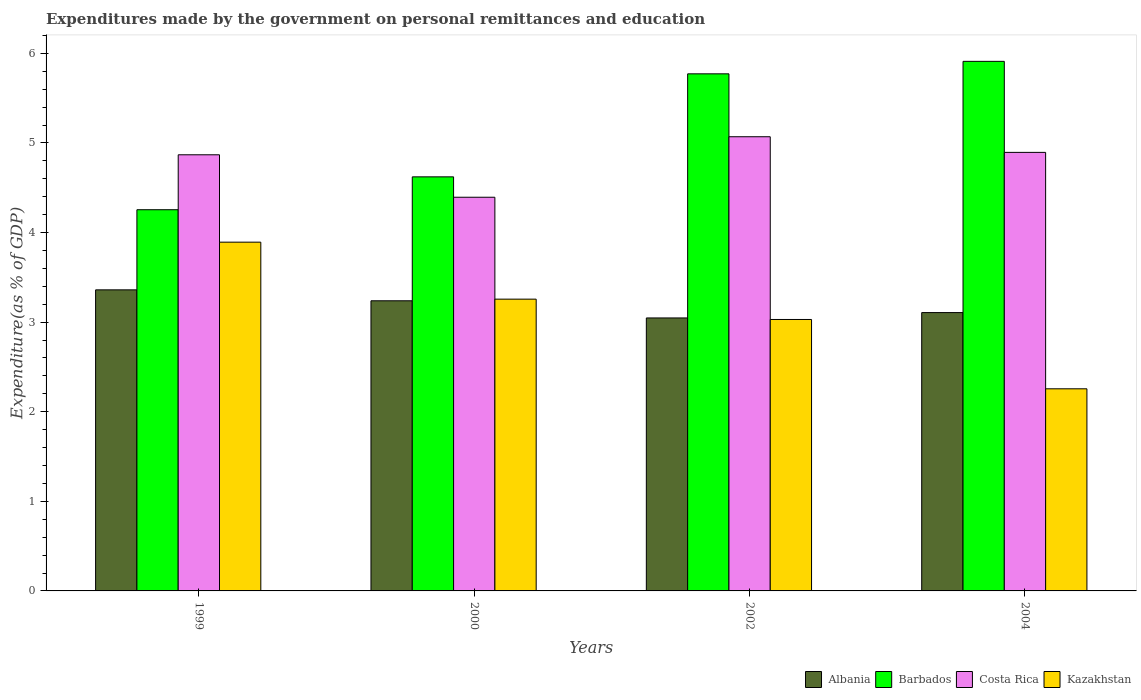How many different coloured bars are there?
Your answer should be compact. 4. How many groups of bars are there?
Make the answer very short. 4. Are the number of bars on each tick of the X-axis equal?
Provide a short and direct response. Yes. How many bars are there on the 1st tick from the left?
Your answer should be compact. 4. How many bars are there on the 4th tick from the right?
Your response must be concise. 4. In how many cases, is the number of bars for a given year not equal to the number of legend labels?
Your answer should be very brief. 0. What is the expenditures made by the government on personal remittances and education in Barbados in 2004?
Your response must be concise. 5.91. Across all years, what is the maximum expenditures made by the government on personal remittances and education in Albania?
Make the answer very short. 3.36. Across all years, what is the minimum expenditures made by the government on personal remittances and education in Costa Rica?
Provide a succinct answer. 4.39. In which year was the expenditures made by the government on personal remittances and education in Barbados maximum?
Your answer should be very brief. 2004. In which year was the expenditures made by the government on personal remittances and education in Kazakhstan minimum?
Offer a terse response. 2004. What is the total expenditures made by the government on personal remittances and education in Costa Rica in the graph?
Keep it short and to the point. 19.23. What is the difference between the expenditures made by the government on personal remittances and education in Albania in 2002 and that in 2004?
Offer a terse response. -0.06. What is the difference between the expenditures made by the government on personal remittances and education in Albania in 2002 and the expenditures made by the government on personal remittances and education in Barbados in 1999?
Ensure brevity in your answer.  -1.21. What is the average expenditures made by the government on personal remittances and education in Barbados per year?
Your response must be concise. 5.14. In the year 1999, what is the difference between the expenditures made by the government on personal remittances and education in Barbados and expenditures made by the government on personal remittances and education in Albania?
Provide a short and direct response. 0.89. In how many years, is the expenditures made by the government on personal remittances and education in Barbados greater than 5.4 %?
Keep it short and to the point. 2. What is the ratio of the expenditures made by the government on personal remittances and education in Costa Rica in 1999 to that in 2004?
Provide a short and direct response. 0.99. Is the expenditures made by the government on personal remittances and education in Costa Rica in 2002 less than that in 2004?
Provide a short and direct response. No. What is the difference between the highest and the second highest expenditures made by the government on personal remittances and education in Costa Rica?
Ensure brevity in your answer.  0.17. What is the difference between the highest and the lowest expenditures made by the government on personal remittances and education in Barbados?
Your answer should be compact. 1.66. In how many years, is the expenditures made by the government on personal remittances and education in Costa Rica greater than the average expenditures made by the government on personal remittances and education in Costa Rica taken over all years?
Your response must be concise. 3. Is it the case that in every year, the sum of the expenditures made by the government on personal remittances and education in Barbados and expenditures made by the government on personal remittances and education in Albania is greater than the sum of expenditures made by the government on personal remittances and education in Costa Rica and expenditures made by the government on personal remittances and education in Kazakhstan?
Ensure brevity in your answer.  Yes. What does the 4th bar from the left in 2004 represents?
Offer a very short reply. Kazakhstan. What does the 1st bar from the right in 2002 represents?
Your response must be concise. Kazakhstan. Is it the case that in every year, the sum of the expenditures made by the government on personal remittances and education in Barbados and expenditures made by the government on personal remittances and education in Costa Rica is greater than the expenditures made by the government on personal remittances and education in Kazakhstan?
Your answer should be compact. Yes. Are all the bars in the graph horizontal?
Offer a terse response. No. How many years are there in the graph?
Your answer should be compact. 4. What is the difference between two consecutive major ticks on the Y-axis?
Offer a terse response. 1. Are the values on the major ticks of Y-axis written in scientific E-notation?
Provide a succinct answer. No. Does the graph contain grids?
Keep it short and to the point. No. How many legend labels are there?
Offer a very short reply. 4. What is the title of the graph?
Keep it short and to the point. Expenditures made by the government on personal remittances and education. What is the label or title of the Y-axis?
Your response must be concise. Expenditure(as % of GDP). What is the Expenditure(as % of GDP) in Albania in 1999?
Provide a short and direct response. 3.36. What is the Expenditure(as % of GDP) of Barbados in 1999?
Provide a succinct answer. 4.25. What is the Expenditure(as % of GDP) in Costa Rica in 1999?
Provide a short and direct response. 4.87. What is the Expenditure(as % of GDP) in Kazakhstan in 1999?
Give a very brief answer. 3.89. What is the Expenditure(as % of GDP) in Albania in 2000?
Provide a succinct answer. 3.24. What is the Expenditure(as % of GDP) in Barbados in 2000?
Offer a terse response. 4.62. What is the Expenditure(as % of GDP) in Costa Rica in 2000?
Provide a short and direct response. 4.39. What is the Expenditure(as % of GDP) in Kazakhstan in 2000?
Offer a very short reply. 3.26. What is the Expenditure(as % of GDP) in Albania in 2002?
Keep it short and to the point. 3.05. What is the Expenditure(as % of GDP) in Barbados in 2002?
Offer a very short reply. 5.77. What is the Expenditure(as % of GDP) of Costa Rica in 2002?
Make the answer very short. 5.07. What is the Expenditure(as % of GDP) in Kazakhstan in 2002?
Your response must be concise. 3.03. What is the Expenditure(as % of GDP) of Albania in 2004?
Keep it short and to the point. 3.11. What is the Expenditure(as % of GDP) in Barbados in 2004?
Your answer should be very brief. 5.91. What is the Expenditure(as % of GDP) of Costa Rica in 2004?
Provide a short and direct response. 4.89. What is the Expenditure(as % of GDP) in Kazakhstan in 2004?
Your response must be concise. 2.26. Across all years, what is the maximum Expenditure(as % of GDP) of Albania?
Give a very brief answer. 3.36. Across all years, what is the maximum Expenditure(as % of GDP) in Barbados?
Your response must be concise. 5.91. Across all years, what is the maximum Expenditure(as % of GDP) in Costa Rica?
Make the answer very short. 5.07. Across all years, what is the maximum Expenditure(as % of GDP) of Kazakhstan?
Keep it short and to the point. 3.89. Across all years, what is the minimum Expenditure(as % of GDP) of Albania?
Offer a terse response. 3.05. Across all years, what is the minimum Expenditure(as % of GDP) in Barbados?
Ensure brevity in your answer.  4.25. Across all years, what is the minimum Expenditure(as % of GDP) in Costa Rica?
Your response must be concise. 4.39. Across all years, what is the minimum Expenditure(as % of GDP) in Kazakhstan?
Make the answer very short. 2.26. What is the total Expenditure(as % of GDP) of Albania in the graph?
Make the answer very short. 12.75. What is the total Expenditure(as % of GDP) in Barbados in the graph?
Make the answer very short. 20.56. What is the total Expenditure(as % of GDP) of Costa Rica in the graph?
Give a very brief answer. 19.23. What is the total Expenditure(as % of GDP) in Kazakhstan in the graph?
Your response must be concise. 12.43. What is the difference between the Expenditure(as % of GDP) of Albania in 1999 and that in 2000?
Your answer should be very brief. 0.12. What is the difference between the Expenditure(as % of GDP) in Barbados in 1999 and that in 2000?
Make the answer very short. -0.37. What is the difference between the Expenditure(as % of GDP) of Costa Rica in 1999 and that in 2000?
Provide a succinct answer. 0.47. What is the difference between the Expenditure(as % of GDP) in Kazakhstan in 1999 and that in 2000?
Your answer should be compact. 0.64. What is the difference between the Expenditure(as % of GDP) of Albania in 1999 and that in 2002?
Provide a succinct answer. 0.31. What is the difference between the Expenditure(as % of GDP) of Barbados in 1999 and that in 2002?
Your response must be concise. -1.52. What is the difference between the Expenditure(as % of GDP) in Costa Rica in 1999 and that in 2002?
Provide a short and direct response. -0.2. What is the difference between the Expenditure(as % of GDP) in Kazakhstan in 1999 and that in 2002?
Keep it short and to the point. 0.86. What is the difference between the Expenditure(as % of GDP) of Albania in 1999 and that in 2004?
Provide a short and direct response. 0.25. What is the difference between the Expenditure(as % of GDP) of Barbados in 1999 and that in 2004?
Make the answer very short. -1.66. What is the difference between the Expenditure(as % of GDP) in Costa Rica in 1999 and that in 2004?
Provide a succinct answer. -0.03. What is the difference between the Expenditure(as % of GDP) of Kazakhstan in 1999 and that in 2004?
Offer a terse response. 1.64. What is the difference between the Expenditure(as % of GDP) of Albania in 2000 and that in 2002?
Ensure brevity in your answer.  0.19. What is the difference between the Expenditure(as % of GDP) in Barbados in 2000 and that in 2002?
Your answer should be very brief. -1.15. What is the difference between the Expenditure(as % of GDP) in Costa Rica in 2000 and that in 2002?
Make the answer very short. -0.68. What is the difference between the Expenditure(as % of GDP) of Kazakhstan in 2000 and that in 2002?
Make the answer very short. 0.23. What is the difference between the Expenditure(as % of GDP) of Albania in 2000 and that in 2004?
Your answer should be very brief. 0.13. What is the difference between the Expenditure(as % of GDP) of Barbados in 2000 and that in 2004?
Your answer should be compact. -1.29. What is the difference between the Expenditure(as % of GDP) in Costa Rica in 2000 and that in 2004?
Provide a short and direct response. -0.5. What is the difference between the Expenditure(as % of GDP) in Kazakhstan in 2000 and that in 2004?
Give a very brief answer. 1. What is the difference between the Expenditure(as % of GDP) of Albania in 2002 and that in 2004?
Your answer should be very brief. -0.06. What is the difference between the Expenditure(as % of GDP) in Barbados in 2002 and that in 2004?
Your response must be concise. -0.14. What is the difference between the Expenditure(as % of GDP) in Costa Rica in 2002 and that in 2004?
Ensure brevity in your answer.  0.17. What is the difference between the Expenditure(as % of GDP) in Kazakhstan in 2002 and that in 2004?
Ensure brevity in your answer.  0.77. What is the difference between the Expenditure(as % of GDP) in Albania in 1999 and the Expenditure(as % of GDP) in Barbados in 2000?
Ensure brevity in your answer.  -1.26. What is the difference between the Expenditure(as % of GDP) in Albania in 1999 and the Expenditure(as % of GDP) in Costa Rica in 2000?
Ensure brevity in your answer.  -1.03. What is the difference between the Expenditure(as % of GDP) of Albania in 1999 and the Expenditure(as % of GDP) of Kazakhstan in 2000?
Provide a short and direct response. 0.1. What is the difference between the Expenditure(as % of GDP) in Barbados in 1999 and the Expenditure(as % of GDP) in Costa Rica in 2000?
Keep it short and to the point. -0.14. What is the difference between the Expenditure(as % of GDP) in Costa Rica in 1999 and the Expenditure(as % of GDP) in Kazakhstan in 2000?
Offer a terse response. 1.61. What is the difference between the Expenditure(as % of GDP) of Albania in 1999 and the Expenditure(as % of GDP) of Barbados in 2002?
Provide a succinct answer. -2.41. What is the difference between the Expenditure(as % of GDP) of Albania in 1999 and the Expenditure(as % of GDP) of Costa Rica in 2002?
Offer a very short reply. -1.71. What is the difference between the Expenditure(as % of GDP) in Albania in 1999 and the Expenditure(as % of GDP) in Kazakhstan in 2002?
Your answer should be compact. 0.33. What is the difference between the Expenditure(as % of GDP) of Barbados in 1999 and the Expenditure(as % of GDP) of Costa Rica in 2002?
Keep it short and to the point. -0.81. What is the difference between the Expenditure(as % of GDP) in Barbados in 1999 and the Expenditure(as % of GDP) in Kazakhstan in 2002?
Your answer should be very brief. 1.22. What is the difference between the Expenditure(as % of GDP) in Costa Rica in 1999 and the Expenditure(as % of GDP) in Kazakhstan in 2002?
Provide a short and direct response. 1.84. What is the difference between the Expenditure(as % of GDP) of Albania in 1999 and the Expenditure(as % of GDP) of Barbados in 2004?
Make the answer very short. -2.55. What is the difference between the Expenditure(as % of GDP) of Albania in 1999 and the Expenditure(as % of GDP) of Costa Rica in 2004?
Give a very brief answer. -1.53. What is the difference between the Expenditure(as % of GDP) of Albania in 1999 and the Expenditure(as % of GDP) of Kazakhstan in 2004?
Your response must be concise. 1.1. What is the difference between the Expenditure(as % of GDP) of Barbados in 1999 and the Expenditure(as % of GDP) of Costa Rica in 2004?
Offer a very short reply. -0.64. What is the difference between the Expenditure(as % of GDP) in Barbados in 1999 and the Expenditure(as % of GDP) in Kazakhstan in 2004?
Your response must be concise. 2. What is the difference between the Expenditure(as % of GDP) in Costa Rica in 1999 and the Expenditure(as % of GDP) in Kazakhstan in 2004?
Your answer should be very brief. 2.61. What is the difference between the Expenditure(as % of GDP) in Albania in 2000 and the Expenditure(as % of GDP) in Barbados in 2002?
Provide a short and direct response. -2.53. What is the difference between the Expenditure(as % of GDP) in Albania in 2000 and the Expenditure(as % of GDP) in Costa Rica in 2002?
Offer a terse response. -1.83. What is the difference between the Expenditure(as % of GDP) in Albania in 2000 and the Expenditure(as % of GDP) in Kazakhstan in 2002?
Keep it short and to the point. 0.21. What is the difference between the Expenditure(as % of GDP) in Barbados in 2000 and the Expenditure(as % of GDP) in Costa Rica in 2002?
Your response must be concise. -0.45. What is the difference between the Expenditure(as % of GDP) in Barbados in 2000 and the Expenditure(as % of GDP) in Kazakhstan in 2002?
Provide a succinct answer. 1.59. What is the difference between the Expenditure(as % of GDP) of Costa Rica in 2000 and the Expenditure(as % of GDP) of Kazakhstan in 2002?
Provide a succinct answer. 1.36. What is the difference between the Expenditure(as % of GDP) of Albania in 2000 and the Expenditure(as % of GDP) of Barbados in 2004?
Provide a short and direct response. -2.67. What is the difference between the Expenditure(as % of GDP) of Albania in 2000 and the Expenditure(as % of GDP) of Costa Rica in 2004?
Provide a short and direct response. -1.66. What is the difference between the Expenditure(as % of GDP) of Albania in 2000 and the Expenditure(as % of GDP) of Kazakhstan in 2004?
Your response must be concise. 0.98. What is the difference between the Expenditure(as % of GDP) in Barbados in 2000 and the Expenditure(as % of GDP) in Costa Rica in 2004?
Provide a succinct answer. -0.27. What is the difference between the Expenditure(as % of GDP) in Barbados in 2000 and the Expenditure(as % of GDP) in Kazakhstan in 2004?
Your answer should be very brief. 2.37. What is the difference between the Expenditure(as % of GDP) of Costa Rica in 2000 and the Expenditure(as % of GDP) of Kazakhstan in 2004?
Provide a short and direct response. 2.14. What is the difference between the Expenditure(as % of GDP) of Albania in 2002 and the Expenditure(as % of GDP) of Barbados in 2004?
Offer a terse response. -2.86. What is the difference between the Expenditure(as % of GDP) in Albania in 2002 and the Expenditure(as % of GDP) in Costa Rica in 2004?
Give a very brief answer. -1.85. What is the difference between the Expenditure(as % of GDP) of Albania in 2002 and the Expenditure(as % of GDP) of Kazakhstan in 2004?
Your response must be concise. 0.79. What is the difference between the Expenditure(as % of GDP) in Barbados in 2002 and the Expenditure(as % of GDP) in Costa Rica in 2004?
Provide a short and direct response. 0.88. What is the difference between the Expenditure(as % of GDP) in Barbados in 2002 and the Expenditure(as % of GDP) in Kazakhstan in 2004?
Offer a very short reply. 3.52. What is the difference between the Expenditure(as % of GDP) of Costa Rica in 2002 and the Expenditure(as % of GDP) of Kazakhstan in 2004?
Offer a terse response. 2.81. What is the average Expenditure(as % of GDP) of Albania per year?
Your answer should be very brief. 3.19. What is the average Expenditure(as % of GDP) of Barbados per year?
Make the answer very short. 5.14. What is the average Expenditure(as % of GDP) in Costa Rica per year?
Give a very brief answer. 4.81. What is the average Expenditure(as % of GDP) of Kazakhstan per year?
Make the answer very short. 3.11. In the year 1999, what is the difference between the Expenditure(as % of GDP) of Albania and Expenditure(as % of GDP) of Barbados?
Keep it short and to the point. -0.89. In the year 1999, what is the difference between the Expenditure(as % of GDP) in Albania and Expenditure(as % of GDP) in Costa Rica?
Provide a short and direct response. -1.51. In the year 1999, what is the difference between the Expenditure(as % of GDP) in Albania and Expenditure(as % of GDP) in Kazakhstan?
Ensure brevity in your answer.  -0.53. In the year 1999, what is the difference between the Expenditure(as % of GDP) of Barbados and Expenditure(as % of GDP) of Costa Rica?
Offer a very short reply. -0.61. In the year 1999, what is the difference between the Expenditure(as % of GDP) in Barbados and Expenditure(as % of GDP) in Kazakhstan?
Keep it short and to the point. 0.36. In the year 1999, what is the difference between the Expenditure(as % of GDP) of Costa Rica and Expenditure(as % of GDP) of Kazakhstan?
Offer a very short reply. 0.98. In the year 2000, what is the difference between the Expenditure(as % of GDP) of Albania and Expenditure(as % of GDP) of Barbados?
Keep it short and to the point. -1.38. In the year 2000, what is the difference between the Expenditure(as % of GDP) in Albania and Expenditure(as % of GDP) in Costa Rica?
Offer a very short reply. -1.16. In the year 2000, what is the difference between the Expenditure(as % of GDP) of Albania and Expenditure(as % of GDP) of Kazakhstan?
Your answer should be compact. -0.02. In the year 2000, what is the difference between the Expenditure(as % of GDP) in Barbados and Expenditure(as % of GDP) in Costa Rica?
Offer a terse response. 0.23. In the year 2000, what is the difference between the Expenditure(as % of GDP) in Barbados and Expenditure(as % of GDP) in Kazakhstan?
Keep it short and to the point. 1.36. In the year 2000, what is the difference between the Expenditure(as % of GDP) in Costa Rica and Expenditure(as % of GDP) in Kazakhstan?
Make the answer very short. 1.14. In the year 2002, what is the difference between the Expenditure(as % of GDP) of Albania and Expenditure(as % of GDP) of Barbados?
Offer a very short reply. -2.72. In the year 2002, what is the difference between the Expenditure(as % of GDP) in Albania and Expenditure(as % of GDP) in Costa Rica?
Keep it short and to the point. -2.02. In the year 2002, what is the difference between the Expenditure(as % of GDP) of Albania and Expenditure(as % of GDP) of Kazakhstan?
Your response must be concise. 0.02. In the year 2002, what is the difference between the Expenditure(as % of GDP) in Barbados and Expenditure(as % of GDP) in Costa Rica?
Give a very brief answer. 0.7. In the year 2002, what is the difference between the Expenditure(as % of GDP) in Barbados and Expenditure(as % of GDP) in Kazakhstan?
Keep it short and to the point. 2.74. In the year 2002, what is the difference between the Expenditure(as % of GDP) in Costa Rica and Expenditure(as % of GDP) in Kazakhstan?
Keep it short and to the point. 2.04. In the year 2004, what is the difference between the Expenditure(as % of GDP) of Albania and Expenditure(as % of GDP) of Barbados?
Your answer should be compact. -2.8. In the year 2004, what is the difference between the Expenditure(as % of GDP) in Albania and Expenditure(as % of GDP) in Costa Rica?
Your response must be concise. -1.79. In the year 2004, what is the difference between the Expenditure(as % of GDP) of Albania and Expenditure(as % of GDP) of Kazakhstan?
Your answer should be very brief. 0.85. In the year 2004, what is the difference between the Expenditure(as % of GDP) of Barbados and Expenditure(as % of GDP) of Costa Rica?
Your answer should be compact. 1.02. In the year 2004, what is the difference between the Expenditure(as % of GDP) of Barbados and Expenditure(as % of GDP) of Kazakhstan?
Ensure brevity in your answer.  3.65. In the year 2004, what is the difference between the Expenditure(as % of GDP) of Costa Rica and Expenditure(as % of GDP) of Kazakhstan?
Provide a short and direct response. 2.64. What is the ratio of the Expenditure(as % of GDP) in Albania in 1999 to that in 2000?
Offer a very short reply. 1.04. What is the ratio of the Expenditure(as % of GDP) of Barbados in 1999 to that in 2000?
Give a very brief answer. 0.92. What is the ratio of the Expenditure(as % of GDP) in Costa Rica in 1999 to that in 2000?
Offer a terse response. 1.11. What is the ratio of the Expenditure(as % of GDP) in Kazakhstan in 1999 to that in 2000?
Your answer should be very brief. 1.2. What is the ratio of the Expenditure(as % of GDP) in Albania in 1999 to that in 2002?
Keep it short and to the point. 1.1. What is the ratio of the Expenditure(as % of GDP) of Barbados in 1999 to that in 2002?
Offer a terse response. 0.74. What is the ratio of the Expenditure(as % of GDP) in Costa Rica in 1999 to that in 2002?
Provide a short and direct response. 0.96. What is the ratio of the Expenditure(as % of GDP) in Kazakhstan in 1999 to that in 2002?
Ensure brevity in your answer.  1.28. What is the ratio of the Expenditure(as % of GDP) in Albania in 1999 to that in 2004?
Provide a succinct answer. 1.08. What is the ratio of the Expenditure(as % of GDP) in Barbados in 1999 to that in 2004?
Your response must be concise. 0.72. What is the ratio of the Expenditure(as % of GDP) in Kazakhstan in 1999 to that in 2004?
Make the answer very short. 1.73. What is the ratio of the Expenditure(as % of GDP) in Albania in 2000 to that in 2002?
Give a very brief answer. 1.06. What is the ratio of the Expenditure(as % of GDP) in Barbados in 2000 to that in 2002?
Offer a very short reply. 0.8. What is the ratio of the Expenditure(as % of GDP) of Costa Rica in 2000 to that in 2002?
Offer a very short reply. 0.87. What is the ratio of the Expenditure(as % of GDP) in Kazakhstan in 2000 to that in 2002?
Ensure brevity in your answer.  1.07. What is the ratio of the Expenditure(as % of GDP) of Albania in 2000 to that in 2004?
Keep it short and to the point. 1.04. What is the ratio of the Expenditure(as % of GDP) of Barbados in 2000 to that in 2004?
Your answer should be compact. 0.78. What is the ratio of the Expenditure(as % of GDP) in Costa Rica in 2000 to that in 2004?
Provide a succinct answer. 0.9. What is the ratio of the Expenditure(as % of GDP) in Kazakhstan in 2000 to that in 2004?
Provide a succinct answer. 1.44. What is the ratio of the Expenditure(as % of GDP) in Albania in 2002 to that in 2004?
Your response must be concise. 0.98. What is the ratio of the Expenditure(as % of GDP) of Barbados in 2002 to that in 2004?
Offer a very short reply. 0.98. What is the ratio of the Expenditure(as % of GDP) in Costa Rica in 2002 to that in 2004?
Ensure brevity in your answer.  1.04. What is the ratio of the Expenditure(as % of GDP) in Kazakhstan in 2002 to that in 2004?
Offer a very short reply. 1.34. What is the difference between the highest and the second highest Expenditure(as % of GDP) of Albania?
Provide a succinct answer. 0.12. What is the difference between the highest and the second highest Expenditure(as % of GDP) in Barbados?
Offer a very short reply. 0.14. What is the difference between the highest and the second highest Expenditure(as % of GDP) of Costa Rica?
Give a very brief answer. 0.17. What is the difference between the highest and the second highest Expenditure(as % of GDP) of Kazakhstan?
Provide a short and direct response. 0.64. What is the difference between the highest and the lowest Expenditure(as % of GDP) in Albania?
Your answer should be compact. 0.31. What is the difference between the highest and the lowest Expenditure(as % of GDP) of Barbados?
Give a very brief answer. 1.66. What is the difference between the highest and the lowest Expenditure(as % of GDP) in Costa Rica?
Your response must be concise. 0.68. What is the difference between the highest and the lowest Expenditure(as % of GDP) of Kazakhstan?
Make the answer very short. 1.64. 